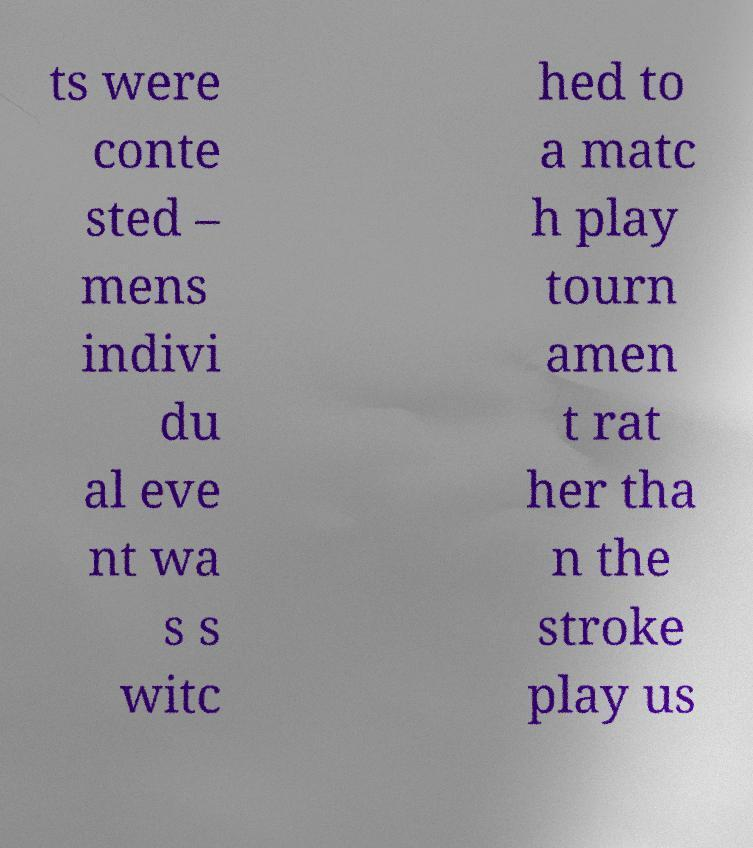Could you extract and type out the text from this image? ts were conte sted – mens indivi du al eve nt wa s s witc hed to a matc h play tourn amen t rat her tha n the stroke play us 